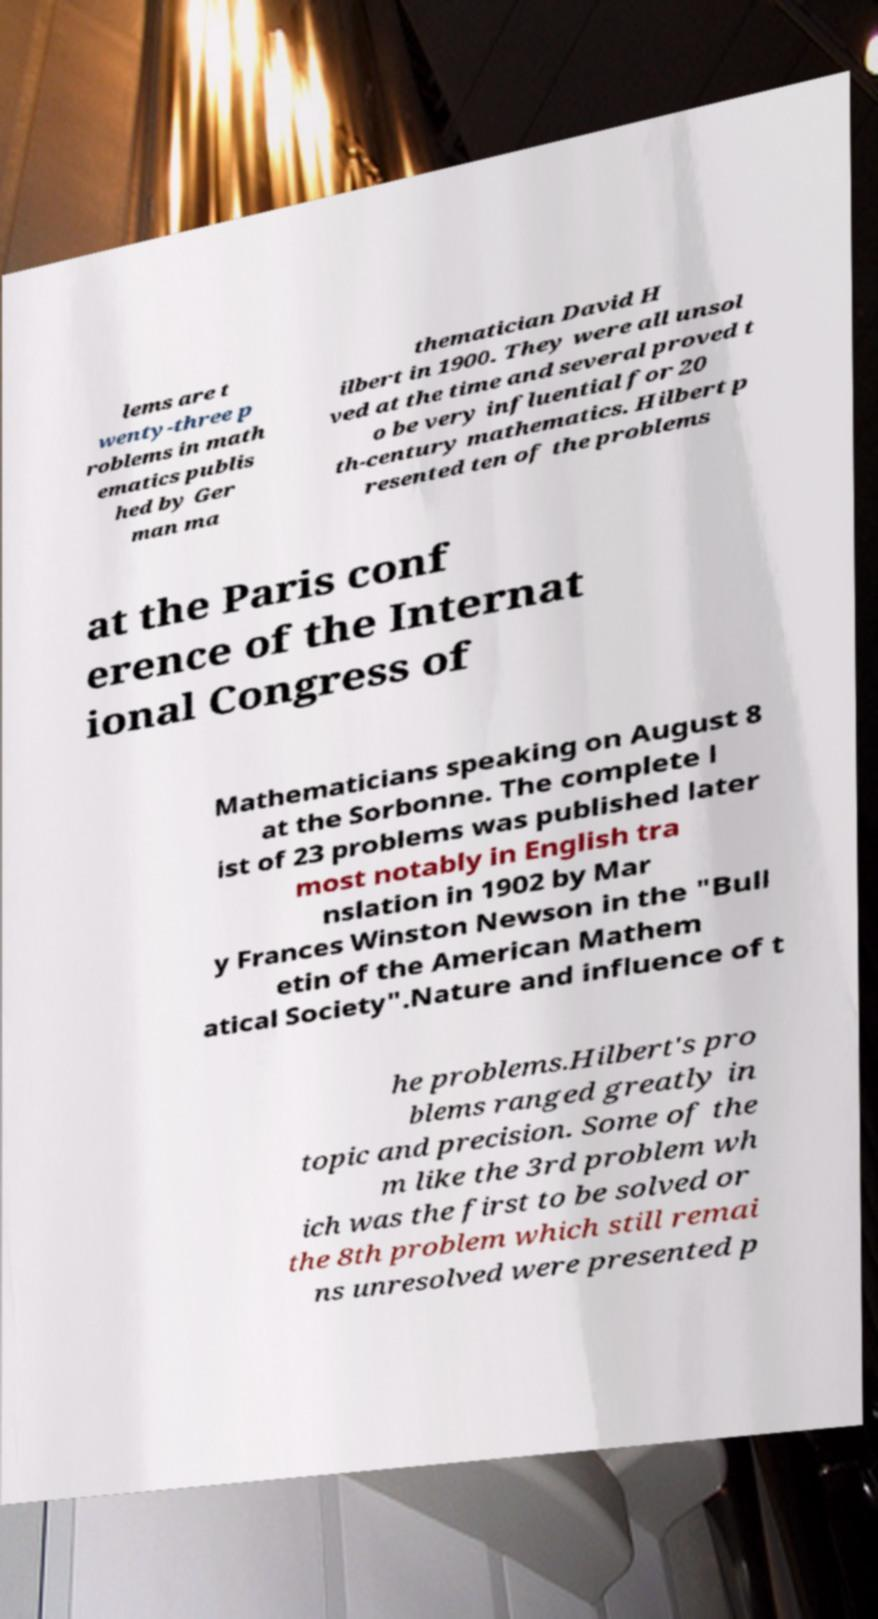What messages or text are displayed in this image? I need them in a readable, typed format. lems are t wenty-three p roblems in math ematics publis hed by Ger man ma thematician David H ilbert in 1900. They were all unsol ved at the time and several proved t o be very influential for 20 th-century mathematics. Hilbert p resented ten of the problems at the Paris conf erence of the Internat ional Congress of Mathematicians speaking on August 8 at the Sorbonne. The complete l ist of 23 problems was published later most notably in English tra nslation in 1902 by Mar y Frances Winston Newson in the "Bull etin of the American Mathem atical Society".Nature and influence of t he problems.Hilbert's pro blems ranged greatly in topic and precision. Some of the m like the 3rd problem wh ich was the first to be solved or the 8th problem which still remai ns unresolved were presented p 